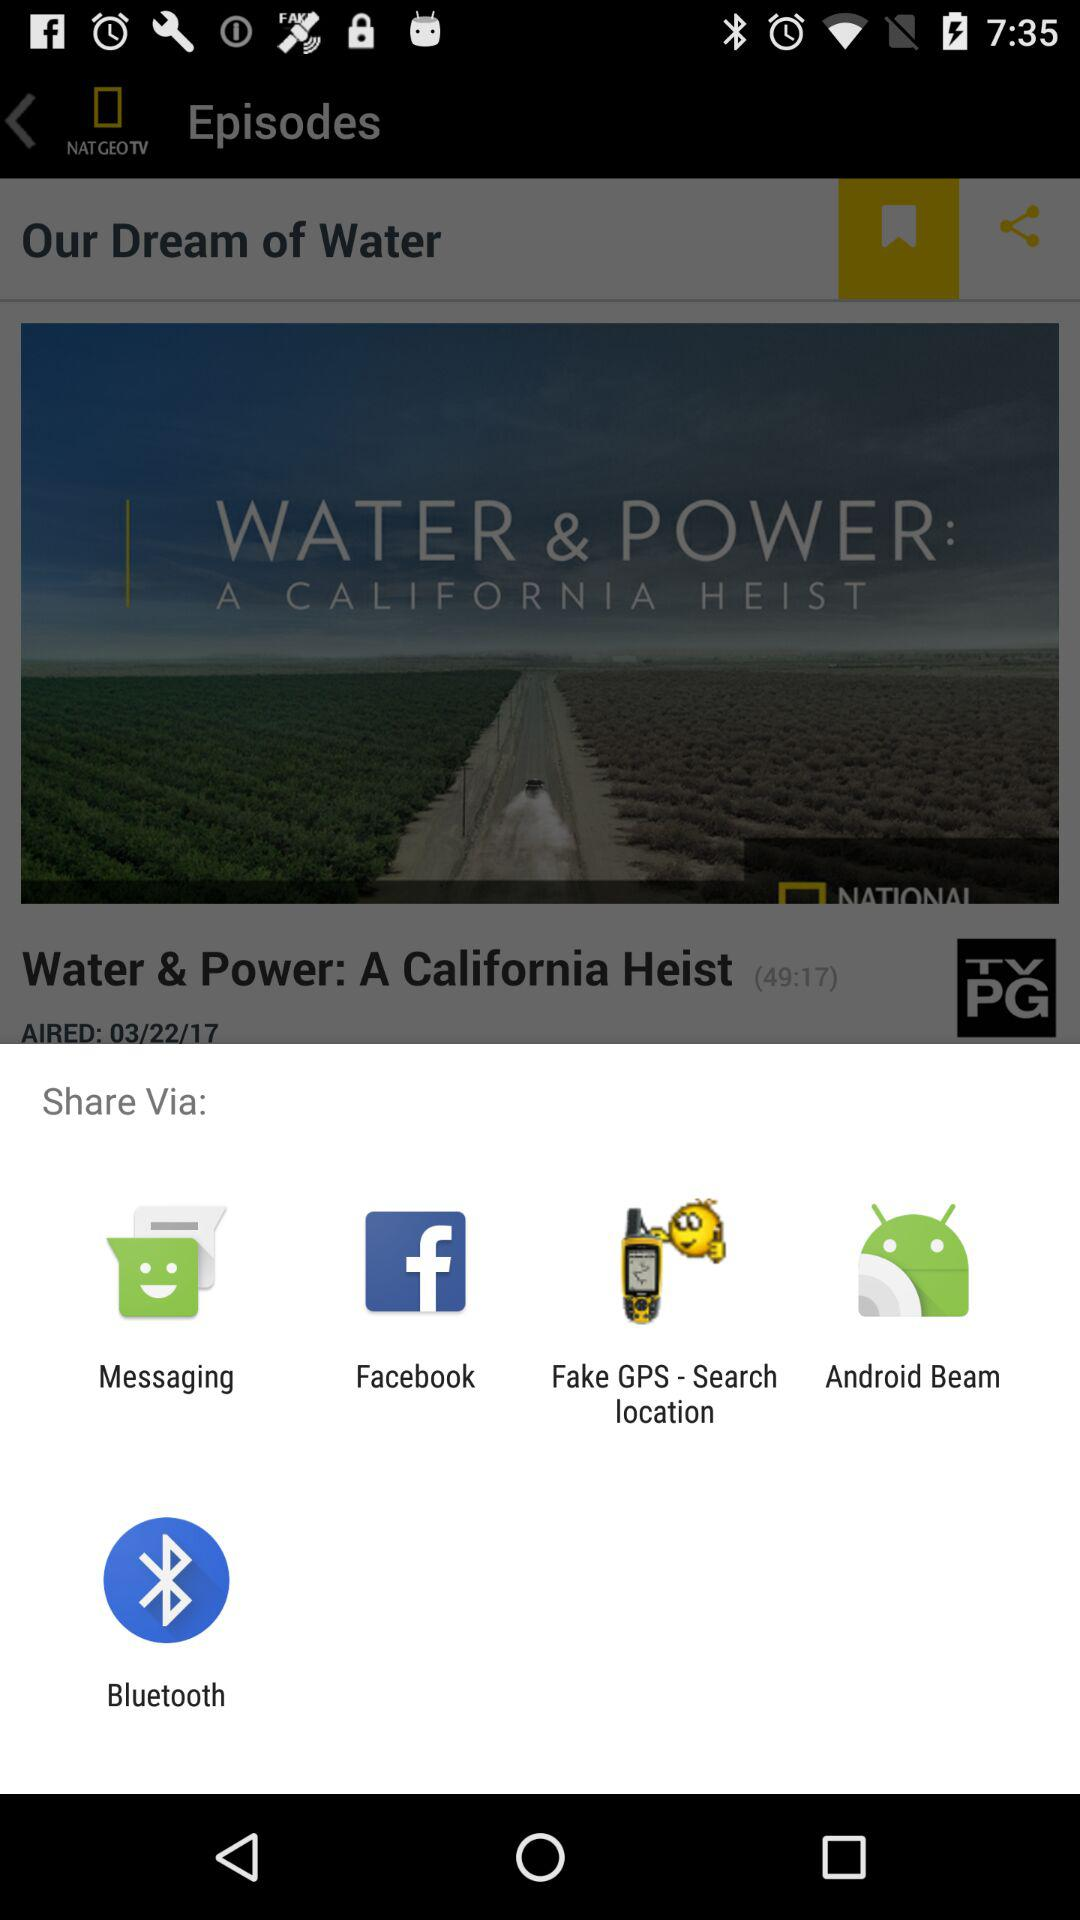On what date did the show "Water & Power: A California Heist" air? The show "Water & Power: A California Heist" aired on March 22, 2017. 